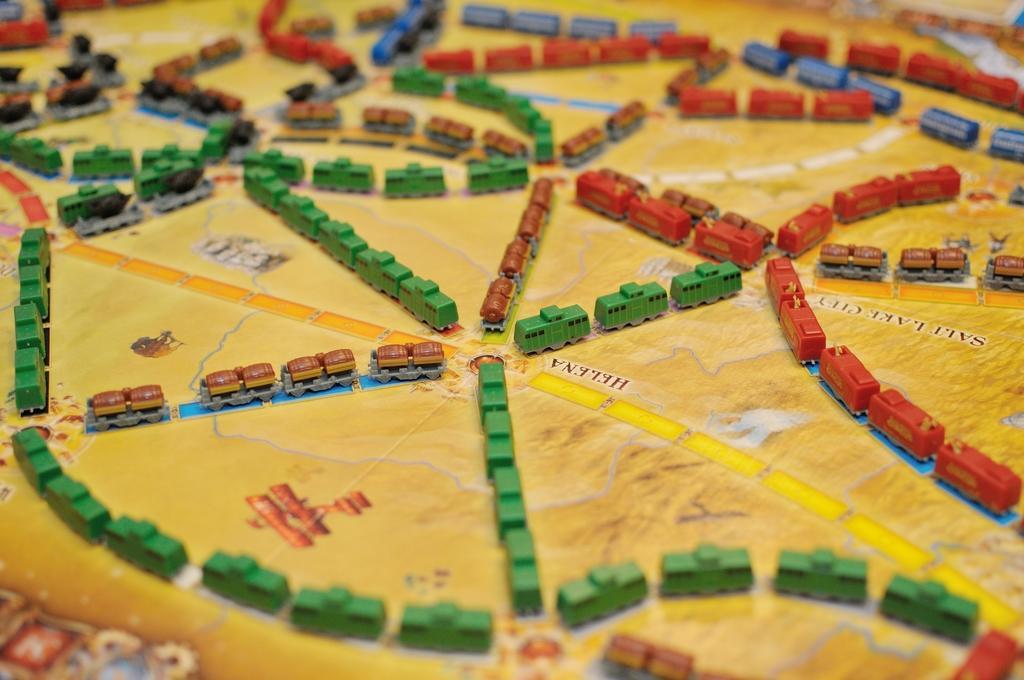Could you give a brief overview of what you see in this image? In this picture we can see toy vehicles on the surface. 